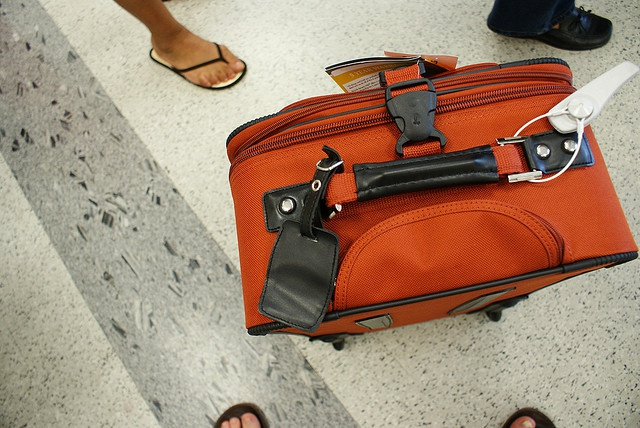Describe the objects in this image and their specific colors. I can see suitcase in gray, brown, red, black, and maroon tones, people in gray, brown, maroon, and tan tones, people in gray, black, darkgray, and navy tones, people in gray, black, salmon, and maroon tones, and people in gray, black, brown, and maroon tones in this image. 